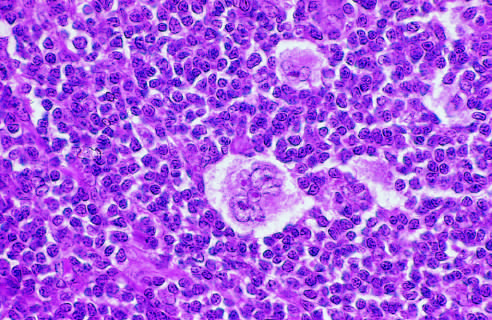 distinctive lacunar cell with a multilobed nucleus containing many small nucleoli is seen lying within a clear space created by retraction of whose cytoplasms?
Answer the question using a single word or phrase. Its 